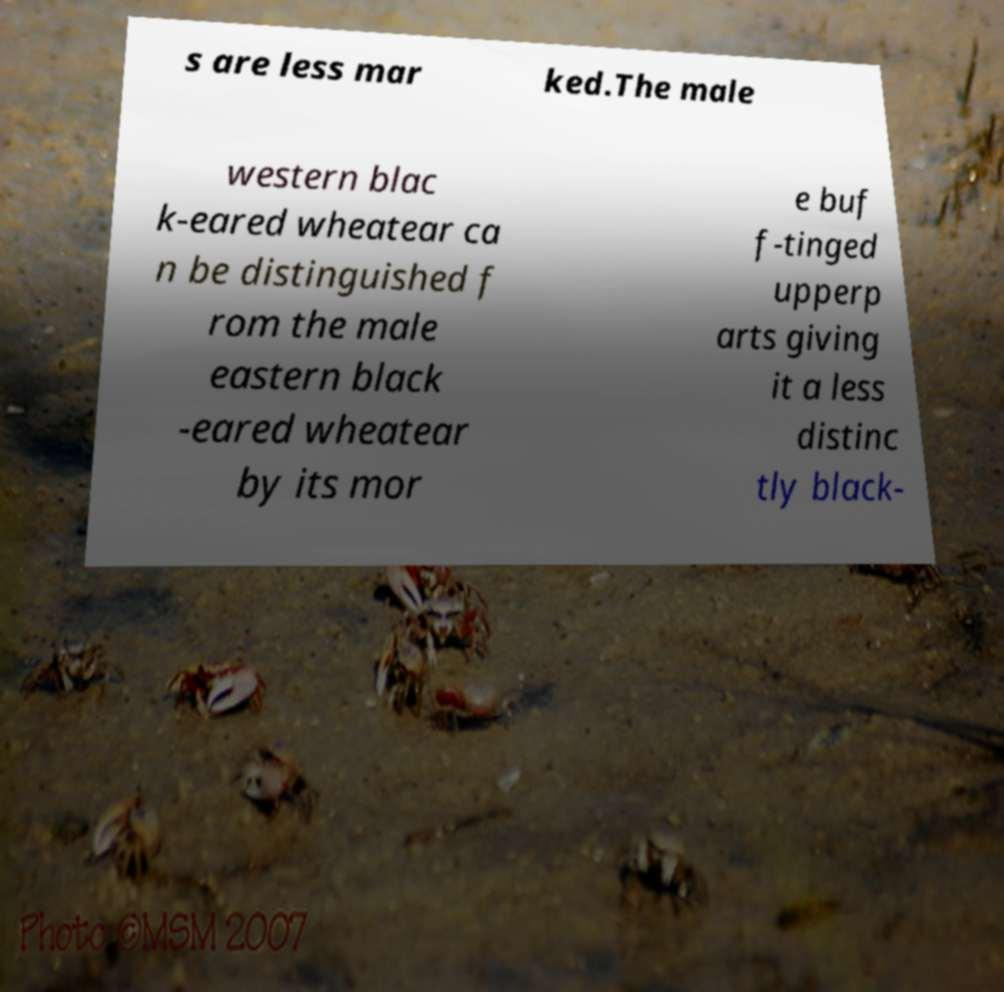Can you read and provide the text displayed in the image?This photo seems to have some interesting text. Can you extract and type it out for me? s are less mar ked.The male western blac k-eared wheatear ca n be distinguished f rom the male eastern black -eared wheatear by its mor e buf f-tinged upperp arts giving it a less distinc tly black- 